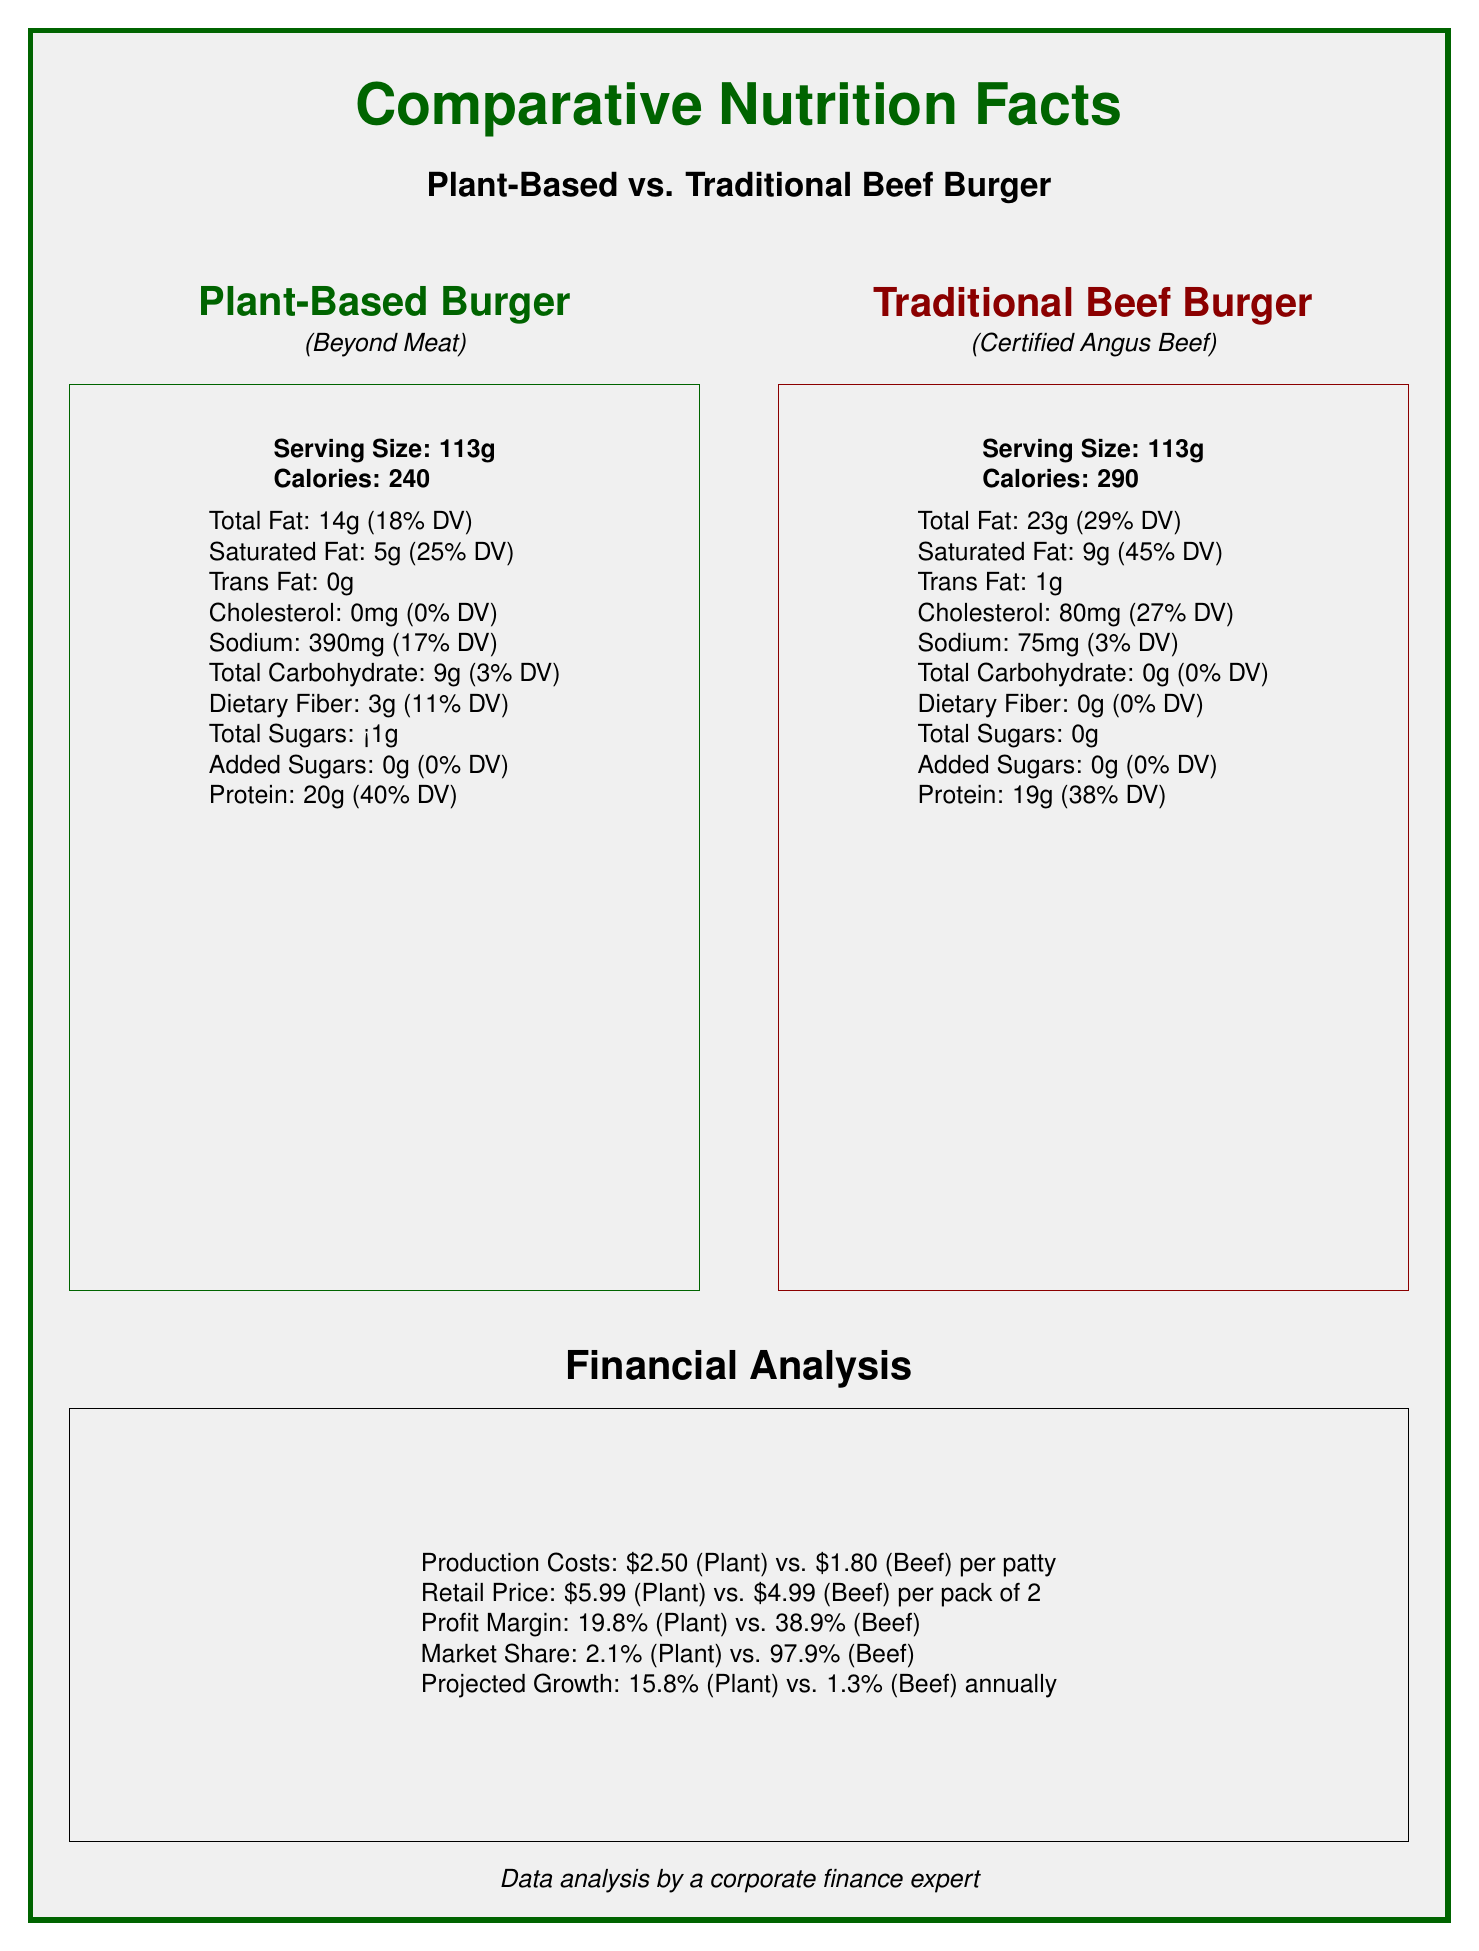what is the serving size for the plant-based burger? The document states that the serving size for the plant-based burger is 113g.
Answer: 113g what is the saturated fat content of the traditional beef burger in grams? The document lists the saturated fat content of the traditional beef burger as 9g.
Answer: 9g how many grams of protein does the plant-based burger contain? According to the document, the plant-based burger contains 20g of protein.
Answer: 20g what is the percentage of the daily value of protein provided by the traditional beef burger? The document shows that the traditional beef burger provides 38% of the daily value for protein.
Answer: 38% what is the cholesterol content in the traditional beef burger? The document states that the cholesterol content in the traditional beef burger is 80mg.
Answer: 80mg which burger has a higher calorie count? A. Plant-Based Burger B. Traditional Beef Burger The plant-based burger has 240 calories, while the traditional beef burger has 290 calories.
Answer: B what are the main ingredients of the traditional beef burger? A. 100% Ground Beef B: Pea Protein C: Refined Coconut Oil D: Mung Bean Protein The document lists the main ingredient of the traditional beef burger as "100% Ground Beef."
Answer: A is there any dietary fiber in the traditional beef burger? The document indicates that there is 0g of dietary fiber in the traditional beef burger.
Answer: No compare the profit margins of the plant-based burger and the traditional beef burger. The document states that the profit margin for the plant-based burger is 19.8% and for the traditional beef burger is 38.9%.
Answer: The profit margin of the plant-based burger is 19.8%, while the profit margin of the traditional beef burger is 38.9%. what is the projected annual growth rate for the plant-based burger market? The document provides a projected growth rate of 15.8% annually for the plant-based burger market.
Answer: 15.8% which burger has a higher amount of sodium? The document indicates that the plant-based burger contains 390mg of sodium, whereas the traditional beef burger contains only 75mg.
Answer: Plant-Based Burger is there any information on the environmental impact of these burgers in the document? The document includes details on environmental factors such as water usage, land use, and greenhouse gas emissions for both types of burgers.
Answer: Yes which burger has a higher protein content per serving? The plant-based burger has 20g of protein per serving, compared to the traditional beef burger's 19g.
Answer: Plant-Based Burger how does the financial analysis section contribute to the understanding of the document? The document includes comparisons of production costs, retail prices, profit margins, market shares, and projected growth, highlighting the economic aspects of both types of burgers.
Answer: The financial analysis section provides insights into the costs, retail prices, profit margins, market shares, and projected growth rates for both plant-based and traditional beef burgers, offering a comprehensive economic comparison between the two. what is the total carbohydrate content in the plant-based burger? The document shows that the total carbohydrate content in the plant-based burger is 9g.
Answer: 9g which burger has higher greenhouse gas emissions? The document indicates that the traditional beef burger has higher greenhouse gas emissions at 1984 kgCO2e per kg of product, compared to the plant-based burger's 90 kgCO2e per kg of product.
Answer: Traditional Beef Burger what brand is the plant-based burger from? The document states that the plant-based burger is from the brand Beyond Meat.
Answer: Beyond Meat which burger has the least environmental impact in terms of land use? The document indicates that the plant-based burger has land use of 93 sqm per kg of product, whereas the traditional beef burger has a land use of 2367 sqm per kg of product.
Answer: Plant-Based Burger can the document provide information on consumer preferences for these burgers? The document provides nutritional, financial, and environmental data but does not include information on consumer preferences.
Answer: Not enough information summarize the main idea of the document. The document compares the nutritional values (like protein and saturated fat), financial aspects (like production costs, profit margins, market shares, projected growth), and environmental impacts (water usage, land use, greenhouse gas emissions) of both plant-based and traditional beef burgers, providing a holistic view of each option.
Answer: The document provides a comprehensive comparison between a plant-based burger (Beyond Meat) and a traditional beef burger (Certified Angus Beef) in terms of nutritional content, financial analysis, and environmental impact. The comparison highlights differences in protein content, saturated fat levels, production costs, market share, and environmental factors such as water usage, land use, and greenhouse gas emissions. 